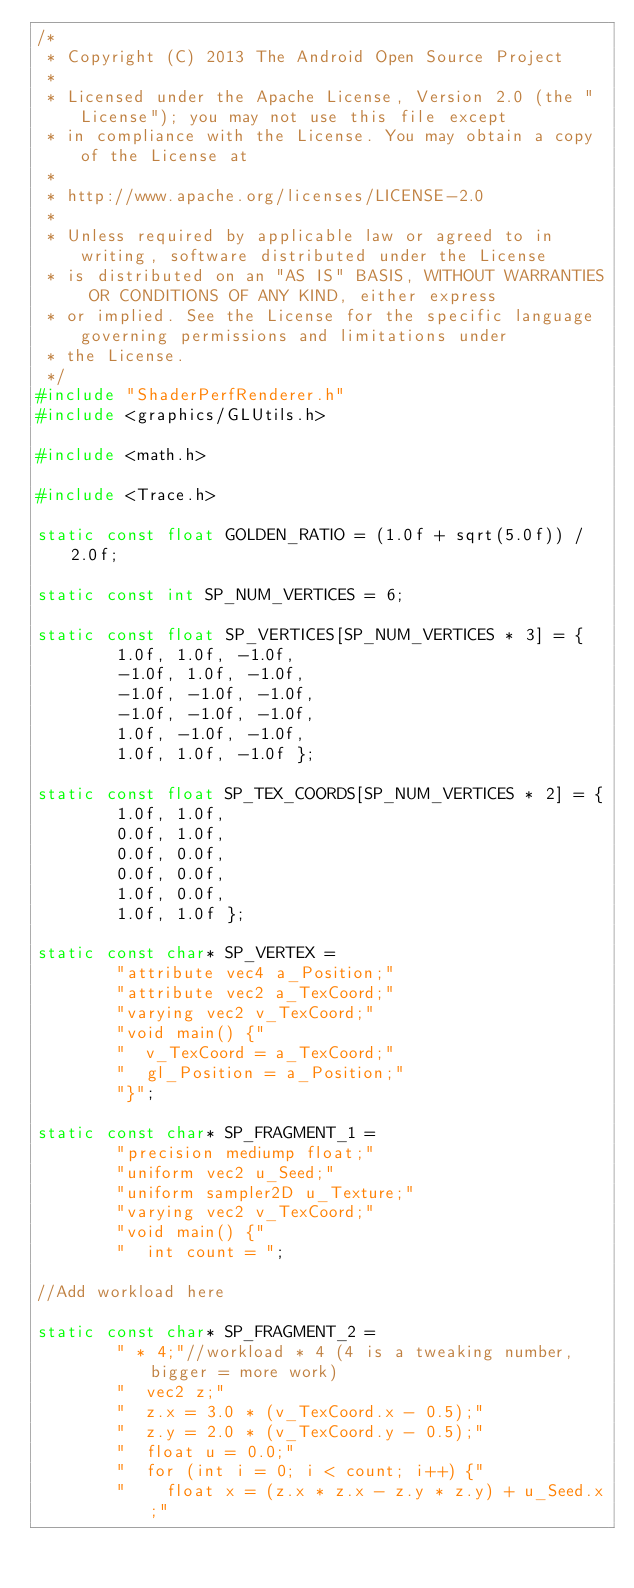Convert code to text. <code><loc_0><loc_0><loc_500><loc_500><_C++_>/*
 * Copyright (C) 2013 The Android Open Source Project
 *
 * Licensed under the Apache License, Version 2.0 (the "License"); you may not use this file except
 * in compliance with the License. You may obtain a copy of the License at
 *
 * http://www.apache.org/licenses/LICENSE-2.0
 *
 * Unless required by applicable law or agreed to in writing, software distributed under the License
 * is distributed on an "AS IS" BASIS, WITHOUT WARRANTIES OR CONDITIONS OF ANY KIND, either express
 * or implied. See the License for the specific language governing permissions and limitations under
 * the License.
 */
#include "ShaderPerfRenderer.h"
#include <graphics/GLUtils.h>

#include <math.h>

#include <Trace.h>

static const float GOLDEN_RATIO = (1.0f + sqrt(5.0f)) / 2.0f;

static const int SP_NUM_VERTICES = 6;

static const float SP_VERTICES[SP_NUM_VERTICES * 3] = {
        1.0f, 1.0f, -1.0f,
        -1.0f, 1.0f, -1.0f,
        -1.0f, -1.0f, -1.0f,
        -1.0f, -1.0f, -1.0f,
        1.0f, -1.0f, -1.0f,
        1.0f, 1.0f, -1.0f };

static const float SP_TEX_COORDS[SP_NUM_VERTICES * 2] = {
        1.0f, 1.0f,
        0.0f, 1.0f,
        0.0f, 0.0f,
        0.0f, 0.0f,
        1.0f, 0.0f,
        1.0f, 1.0f };

static const char* SP_VERTEX =
        "attribute vec4 a_Position;"
        "attribute vec2 a_TexCoord;"
        "varying vec2 v_TexCoord;"
        "void main() {"
        "  v_TexCoord = a_TexCoord;"
        "  gl_Position = a_Position;"
        "}";

static const char* SP_FRAGMENT_1 =
        "precision mediump float;"
        "uniform vec2 u_Seed;"
        "uniform sampler2D u_Texture;"
        "varying vec2 v_TexCoord;"
        "void main() {"
        "  int count = ";

//Add workload here

static const char* SP_FRAGMENT_2 =
        " * 4;"//workload * 4 (4 is a tweaking number, bigger = more work)
        "  vec2 z;"
        "  z.x = 3.0 * (v_TexCoord.x - 0.5);"
        "  z.y = 2.0 * (v_TexCoord.y - 0.5);"
        "  float u = 0.0;"
        "  for (int i = 0; i < count; i++) {"
        "    float x = (z.x * z.x - z.y * z.y) + u_Seed.x;"</code> 